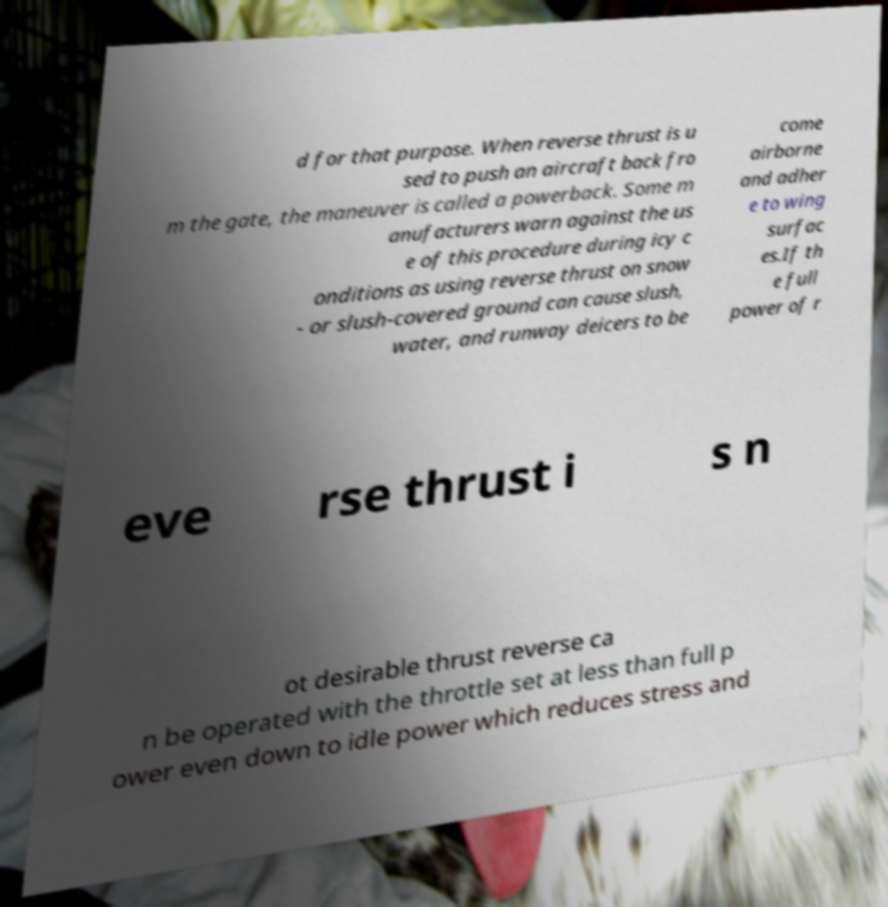Please read and relay the text visible in this image. What does it say? d for that purpose. When reverse thrust is u sed to push an aircraft back fro m the gate, the maneuver is called a powerback. Some m anufacturers warn against the us e of this procedure during icy c onditions as using reverse thrust on snow - or slush-covered ground can cause slush, water, and runway deicers to be come airborne and adher e to wing surfac es.If th e full power of r eve rse thrust i s n ot desirable thrust reverse ca n be operated with the throttle set at less than full p ower even down to idle power which reduces stress and 